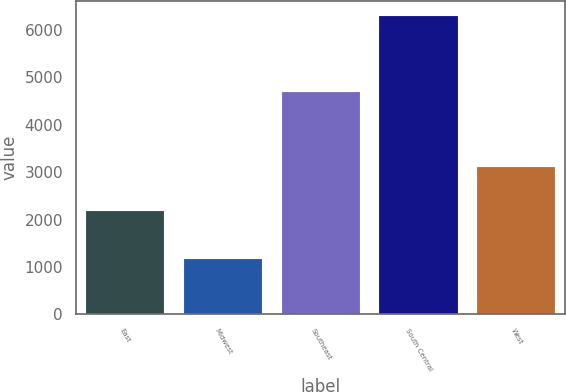Convert chart. <chart><loc_0><loc_0><loc_500><loc_500><bar_chart><fcel>East<fcel>Midwest<fcel>Southeast<fcel>South Central<fcel>West<nl><fcel>2187<fcel>1164<fcel>4682<fcel>6300<fcel>3115<nl></chart> 